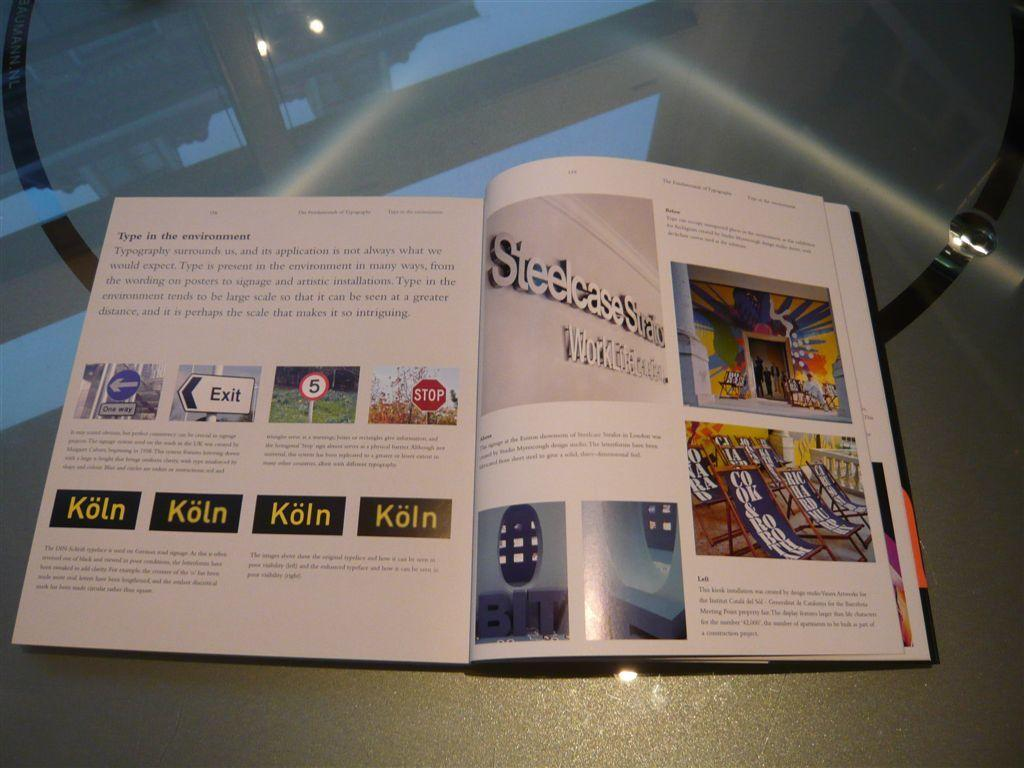<image>
Describe the image concisely. A booklet is open with a page that has Koln in yellow text four times. 